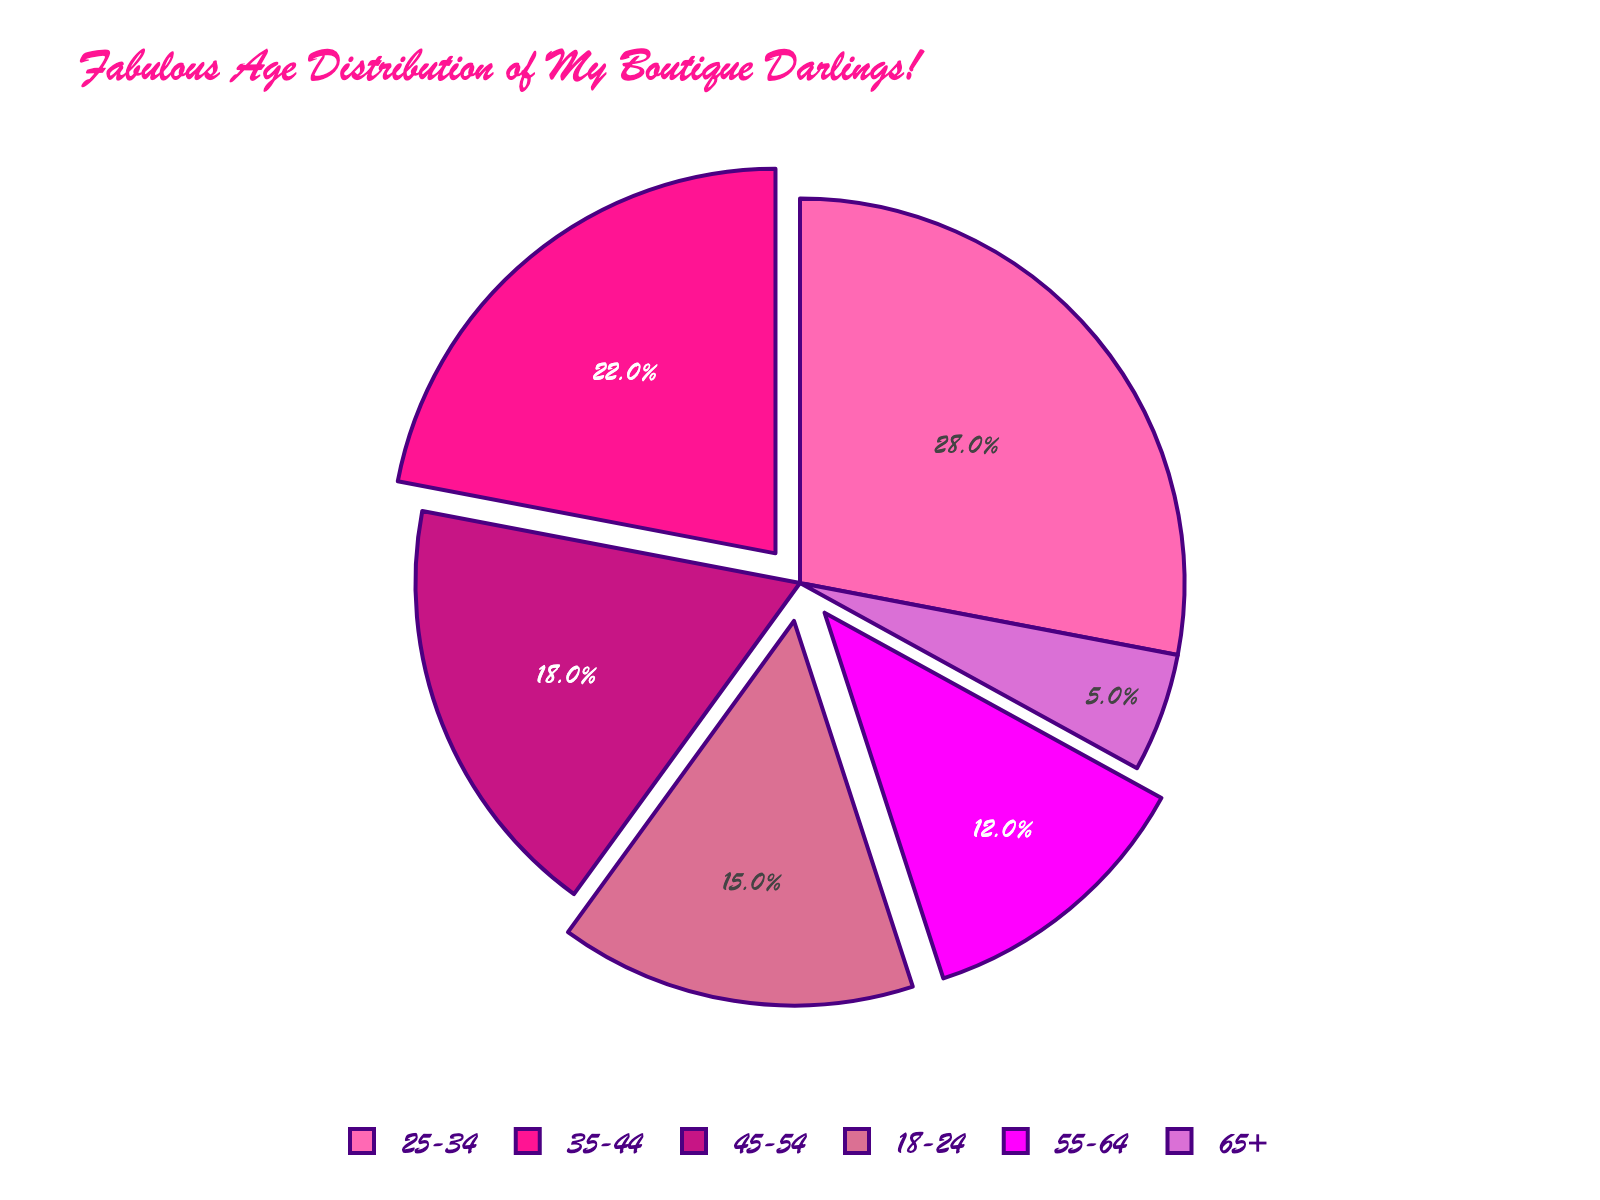Which age group has the largest percentage of customers? From the pie chart, the age group with the largest section is 25-34 years. Verify by the percentage label which shows 28%.
Answer: 25-34 years Which age group contributes the least to the boutique’s customer base? Observing the pie chart, the age group with the smallest section is 65+ years. Verify by the percentage label which shows 5%.
Answer: 65+ years What is the difference in percentage between the 25-34 age group and the 65+ age group? The 25-34 age group has 28%, and the 65+ age group has 5%. The difference is calculated as 28 - 5 = 23%.
Answer: 23% Which age groups constitute more than half of the boutique’s customers combined? The age groups with the largest percentages are checked cumulatively: 25-34 (28%), 35-44 (22%), and 18-24 (15%). Summing them: 28 + 22 + 15 = 65%, which is more than half.
Answer: 18-24, 25-34, and 35-44 years By how much does the percentage of the 45-54 age group exceed the percentage of the 55-64 age group? The percentage of the 45-54 age group is 18% and the 55-64 age group is 12%. The difference is 18 - 12 = 6%.
Answer: 6% What percentage of the boutique's customers are 35-54 years old? The 35-44 age group is 22% and the 45-54 age group is 18%. Adding them gives 22 + 18 = 40%.
Answer: 40% What three-colored segments stand out most vibrantly in the pie chart? The brightest colors used, which are typically more vibrant, relate to the largest sections: hot pink (18-24), deep pink (25-34), and medium violet red (35-44).
Answer: Hot pink, deep pink, medium violet red If the total number of customers is 1,000, how many customers are aged 55 and older? The age groups are 55-64 with 12% and 65+ with 5%. Summing them, (12 + 5)% of 1000 = 17% × 1000 = 170 customers.
Answer: 170 